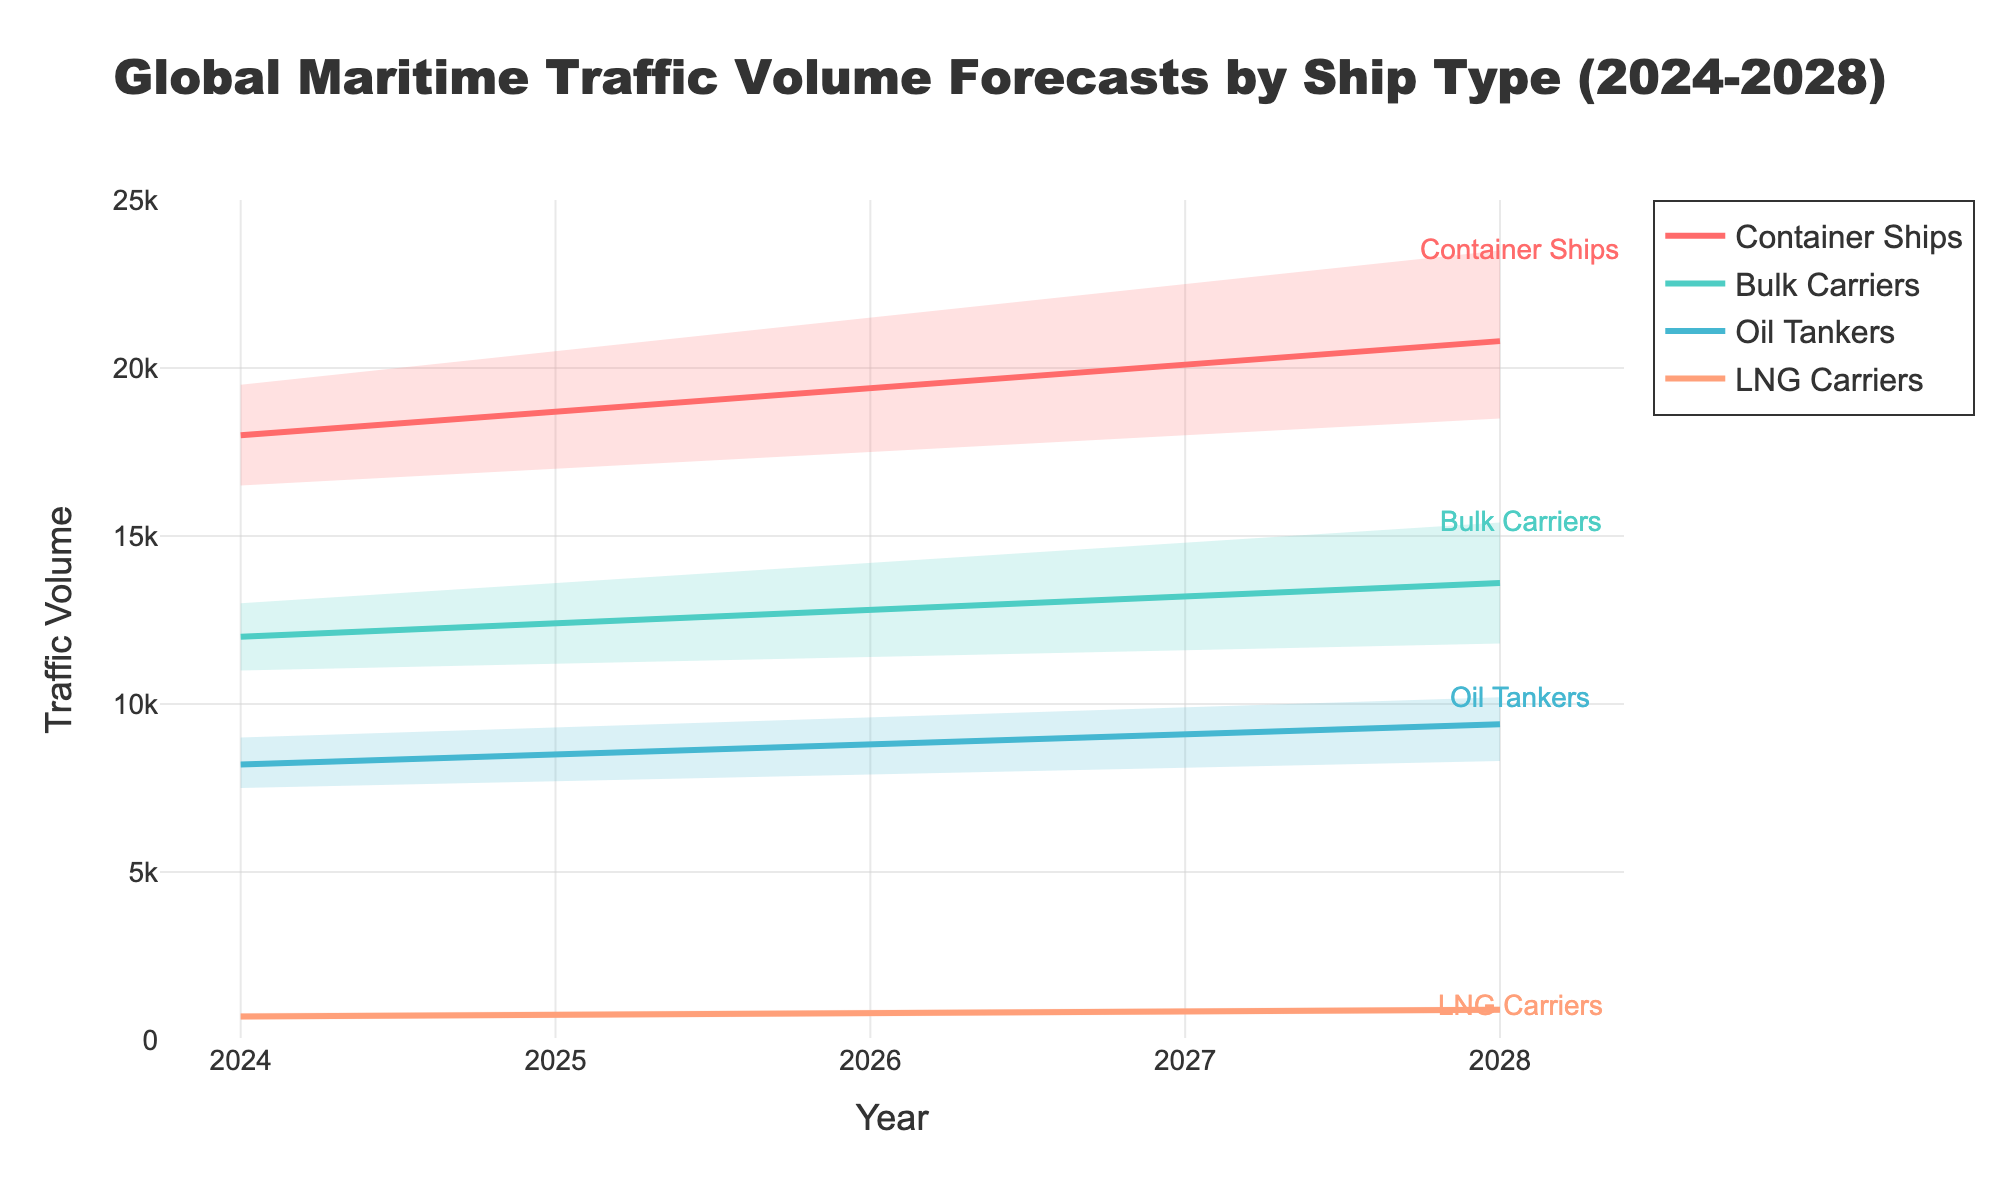What is the title of the figure? The title of the figure is prominently displayed at the top and reads "Global Maritime Traffic Volume Forecasts by Ship Type (2024-2028)".
Answer: Global Maritime Traffic Volume Forecasts by Ship Type (2024-2028) How many ship types are represented in the figure? The figure includes distinct areas and lines for each ship type, and annotations are used to label them. By counting these ship type labels, we find four distinct categories: Container Ships, Bulk Carriers, Oil Tankers, and LNG Carriers.
Answer: 4 What is the expected mid estimate traffic volume for Container Ships in 2026? Locate the line corresponding to Container Ships for the year 2026, and refer to the mid estimate value indicated on the y-axis directly by following the line.
Answer: 19400 Which ship type has the smallest increase in high estimate traffic volume from 2024 to 2028? Observe the top boundary area for each ship type at the start (2024) and end (2028). LNG Carriers show the smallest increase, from 800 to 1000.
Answer: LNG Carriers By how much is the high estimate for Bulk Carriers expected to grow between 2024 and 2028? Subtract the high estimate value of Bulk Carriers in 2024 (13000) from the high estimate value in 2028 (15400).
Answer: 2400 Which ship type shows the greatest variability in estimates for 2028? The variability can be seen as the gap between the low and high estimates of each ship type in 2028. Container Ships, with values ranging from 18500 to 23500, show the greatest variability.
Answer: Container Ships In which year is the mid estimate traffic volume for Oil Tankers projected to exceed 9000? Follow the mid estimate line for Oil Tankers across the years and identify the first year where the value surpasses 9000. This occurs in 2027.
Answer: 2027 What is the average mid estimate traffic volume for LNG Carriers from 2024 to 2028? Sum the mid estimates for LNG Carriers across the five years (700, 750, 800, 850, 900), and divide by 5.
Answer: 800 Which ship type has the steepest increase in mid estimate traffic volume between 2024 and 2028? Compare the slopes of the mid estimate lines among the ship types. Container Ships, rising from 18000 to 20800, have the steepest increase.
Answer: Container Ships What is the difference between the high and low estimate for Oil Tankers in 2026? For the year 2026, subtract the low estimate value for Oil Tankers (7900) from the high estimate value (9600).
Answer: 1700 